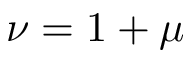<formula> <loc_0><loc_0><loc_500><loc_500>\nu = 1 + \mu</formula> 